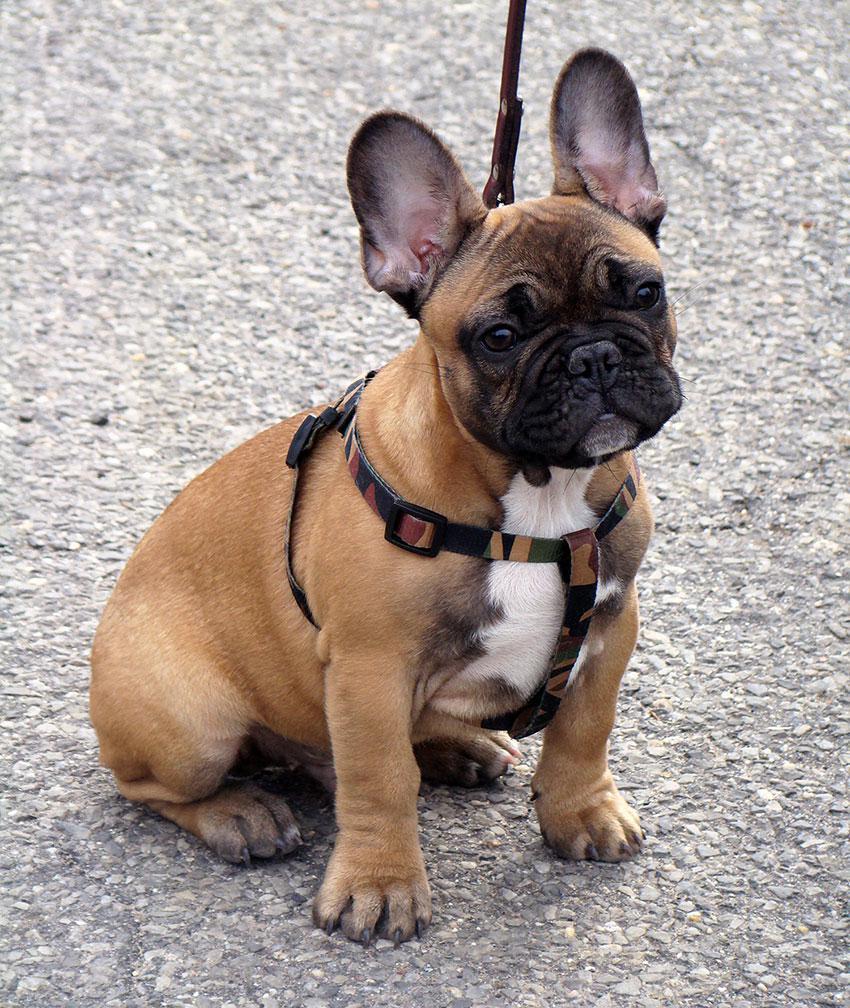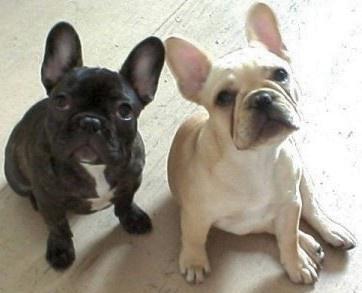The first image is the image on the left, the second image is the image on the right. Assess this claim about the two images: "There are exactly three dogs in total.". Correct or not? Answer yes or no. Yes. 